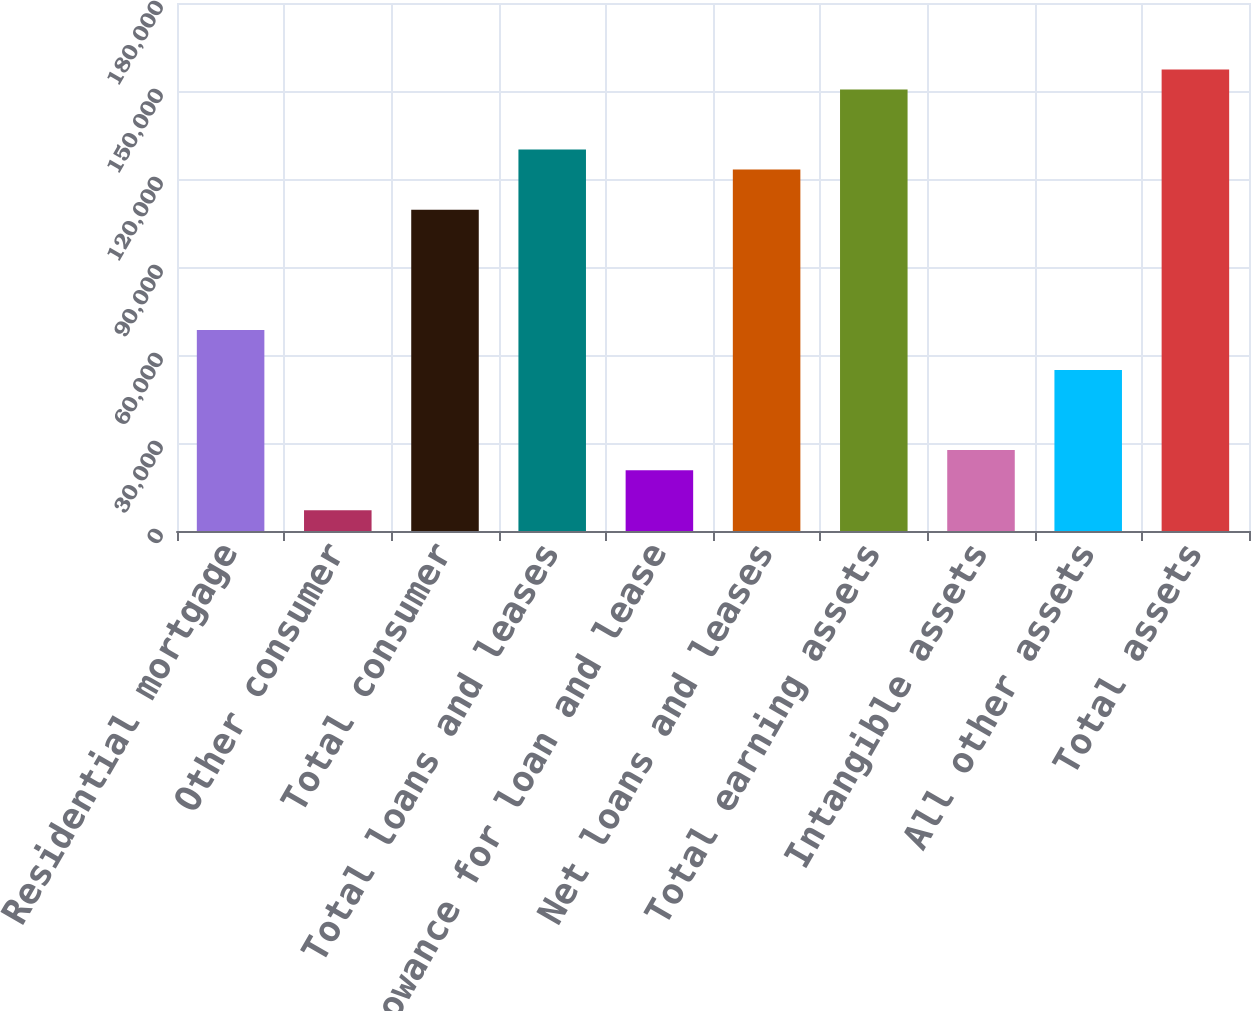<chart> <loc_0><loc_0><loc_500><loc_500><bar_chart><fcel>Residential mortgage<fcel>Other consumer<fcel>Total consumer<fcel>Total loans and leases<fcel>Allowance for loan and lease<fcel>Net loans and leases<fcel>Total earning assets<fcel>Intangible assets<fcel>All other assets<fcel>Total assets<nl><fcel>68560<fcel>7086.4<fcel>109542<fcel>130034<fcel>20747.2<fcel>123203<fcel>150525<fcel>27577.6<fcel>54899.2<fcel>157355<nl></chart> 